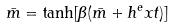<formula> <loc_0><loc_0><loc_500><loc_500>\bar { m } = \tanh [ \beta ( \bar { m } + h ^ { e } x t ) ]</formula> 